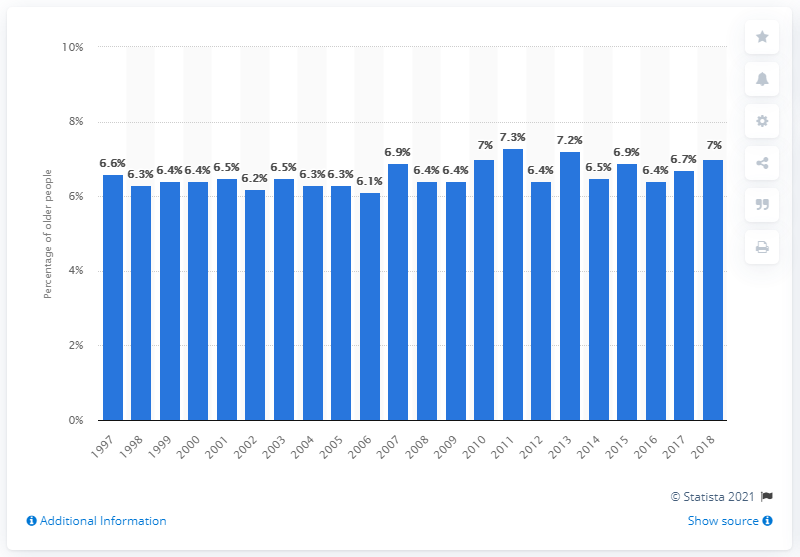Point out several critical features in this image. In 2018, approximately 7% of adults aged 65 and older in the United States required assistance with personal care from other individuals, according to data. 